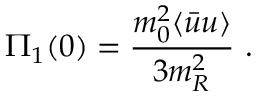Convert formula to latex. <formula><loc_0><loc_0><loc_500><loc_500>\Pi _ { 1 } ( 0 ) = { \frac { m _ { 0 } ^ { 2 } \langle \bar { u } u \rangle } { 3 m _ { R } ^ { 2 } } } \ .</formula> 